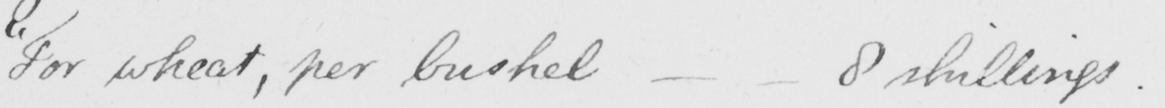Transcribe the text shown in this historical manuscript line. " For wheat , per bushel  _   _  8 shillings . 